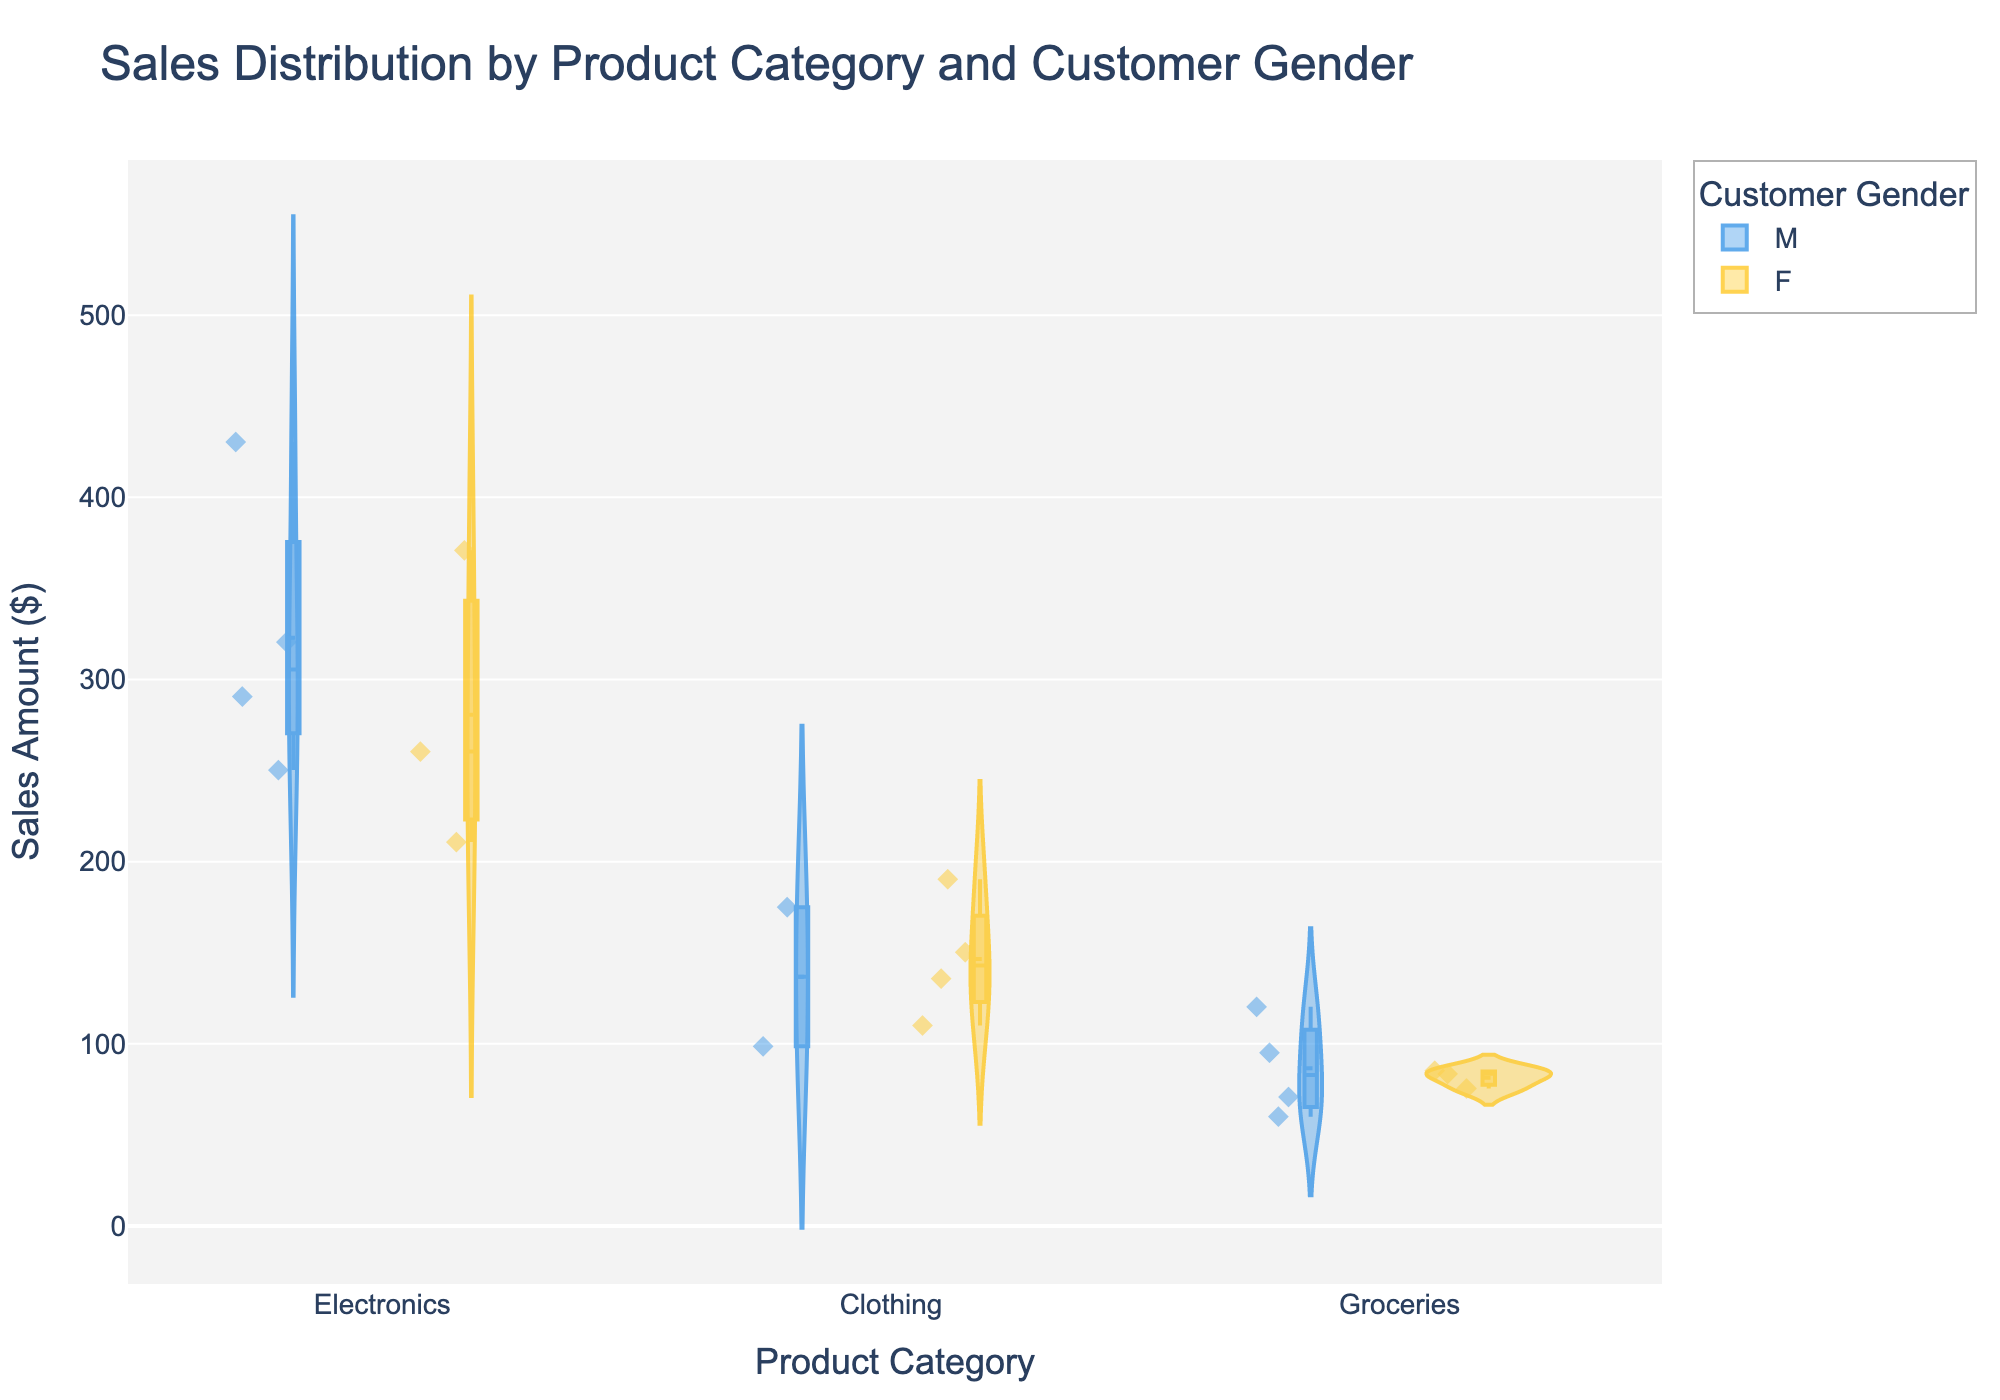What is the title of the figure? The title of the figure is displayed at the top.
Answer: Sales Distribution by Product Category and Customer Gender What are the product categories shown on the x-axis? The x-axis labels represent the different product categories.
Answer: Electronics, Clothing, Groceries Which gender has the most points in the Clothing category? By looking at the points within the Clothing category, we can count the number of points for each gender (color-coded).
Answer: Female What is the general shape of the sales distribution for Groceries? The shape of the violin plot in the Groceries category indicates the distribution of sales amounts.
Answer: Narrower and more uniform, with a slight wider area in the lower range How does the median sales amount for Electronics compare between male and female customers? The median line within each colored violin plot represents the median sales amount; compare the median lines for male (blue) and female (yellow) in the Electronics category.
Answer: Median for males is higher Which product category has the widest range of sales amounts? The range of sales amounts can be observed by looking at the height of the violin plots from the lowest to the highest point within each category.
Answer: Electronics How do the sales amounts vary within the Clothing category based on customer age? Hovering over the jittered points will show additional data, including customer age, allowing us to see variation based on age within the Clothing category.
Answer: Varies, customers are mostly aged between 22 and 48 Are there more high-value sales (above $300) in Electronics for male or female customers? By examining the points above $300 in the Electronics category and counting them for each gender color (blue for male, yellow for female).
Answer: Male What is the average monthly income of the female customers in the Groceries category? Hover over the points in the Groceries category for female customers, sum the monthly incomes, and divide by the number of points.
Answer: Approximately $4475 Do male or female customers have higher monthly incomes in the Electronics category? By comparing the monthly income data from hovering over the points in the Electronics category for both genders.
Answer: Male 